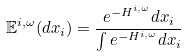Convert formula to latex. <formula><loc_0><loc_0><loc_500><loc_500>\mathbb { E } ^ { i , \omega } ( d x _ { i } ) = \frac { e ^ { - H ^ { i , \omega } } d x _ { i } } { \int e ^ { - H ^ { i , \omega } } d x _ { i } }</formula> 